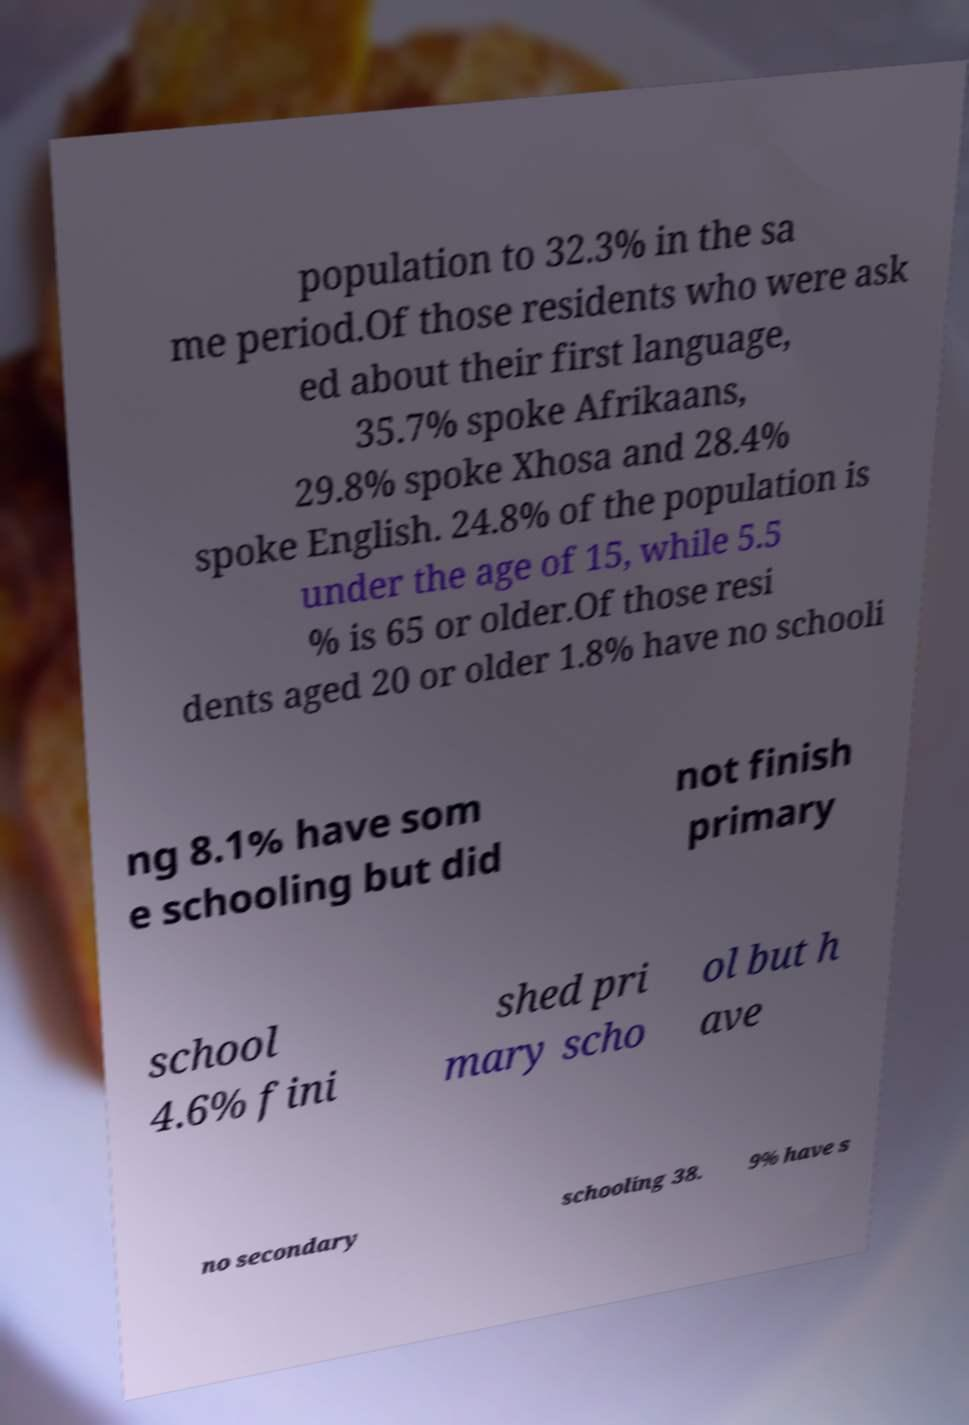For documentation purposes, I need the text within this image transcribed. Could you provide that? population to 32.3% in the sa me period.Of those residents who were ask ed about their first language, 35.7% spoke Afrikaans, 29.8% spoke Xhosa and 28.4% spoke English. 24.8% of the population is under the age of 15, while 5.5 % is 65 or older.Of those resi dents aged 20 or older 1.8% have no schooli ng 8.1% have som e schooling but did not finish primary school 4.6% fini shed pri mary scho ol but h ave no secondary schooling 38. 9% have s 